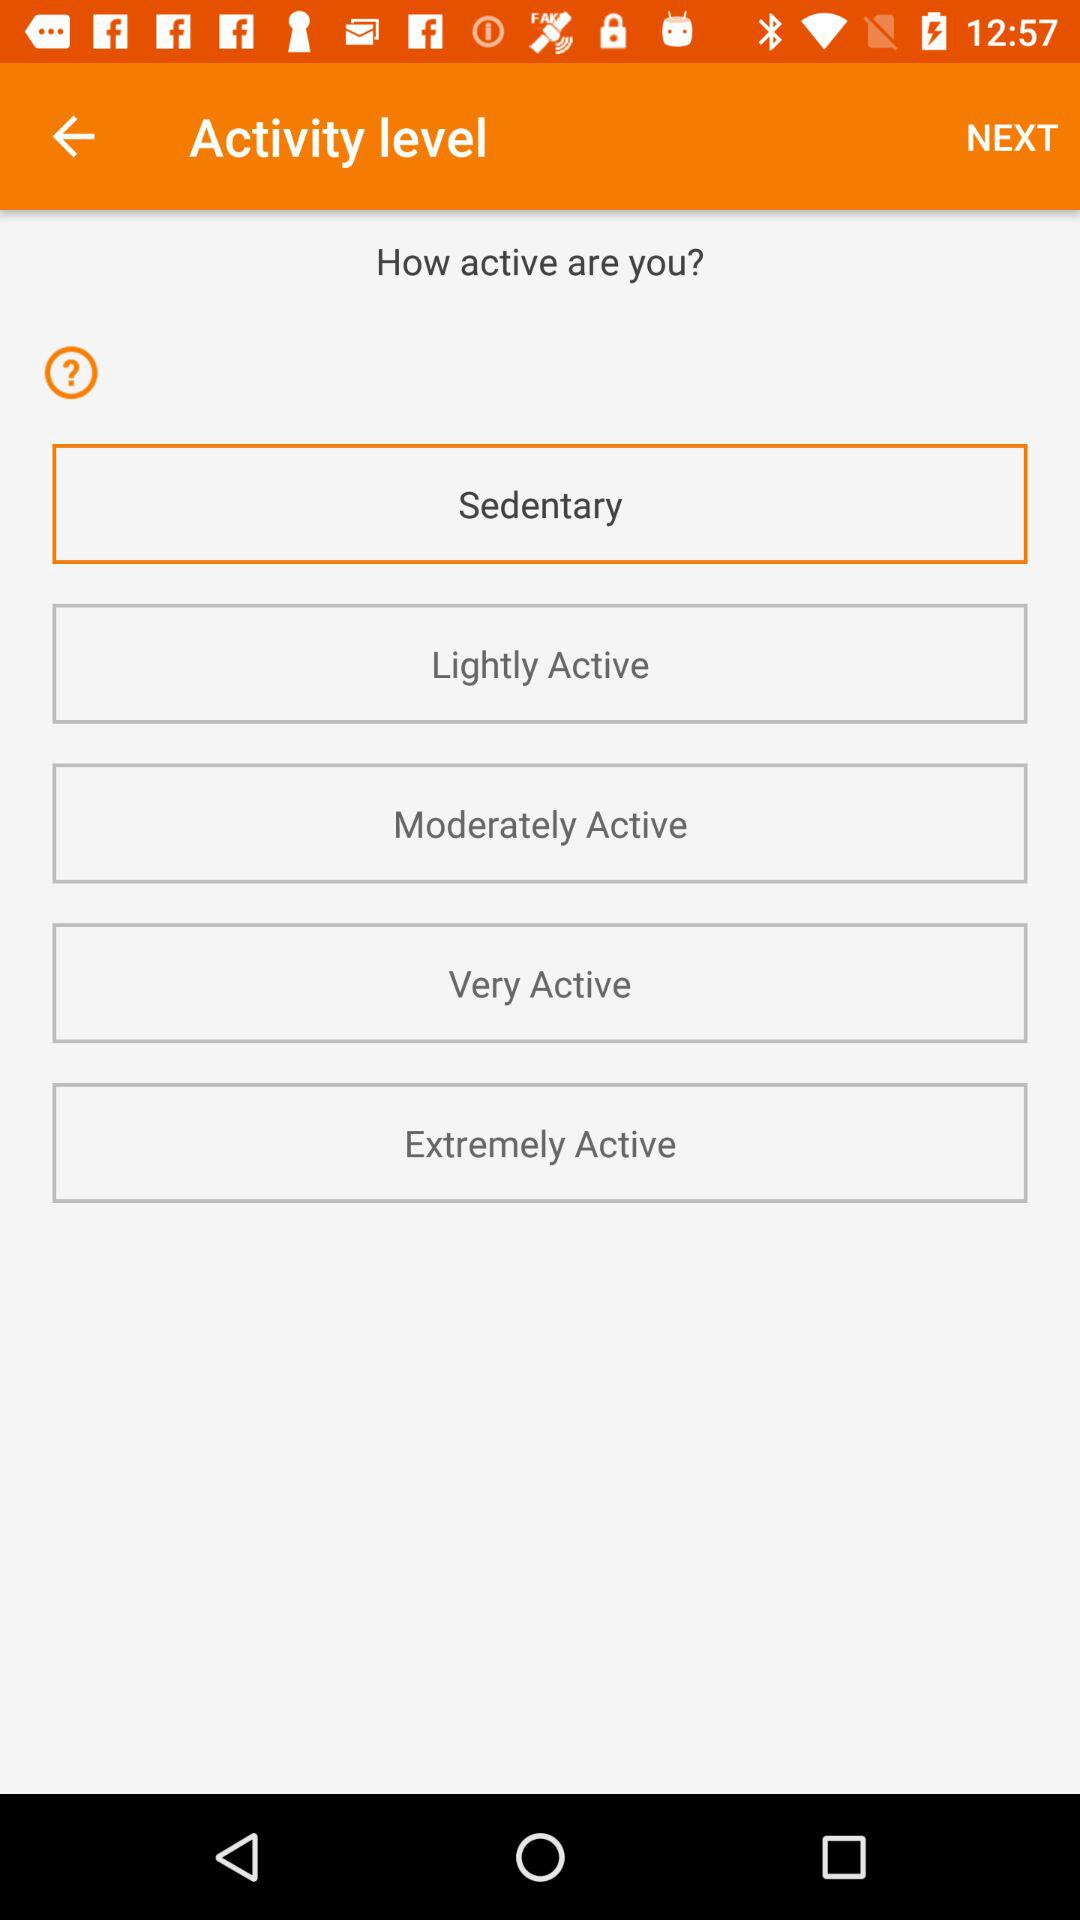How many activity levels are there?
Answer the question using a single word or phrase. 5 